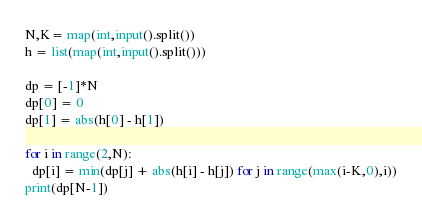<code> <loc_0><loc_0><loc_500><loc_500><_Python_>N,K= map(int,input().split())
h = list(map(int,input().split()))

dp = [-1]*N
dp[0] = 0
dp[1] = abs(h[0] - h[1])

for i in range(2,N):
  dp[i] = min(dp[j] + abs(h[i] - h[j]) for j in range(max(i-K,0),i))
print(dp[N-1])</code> 